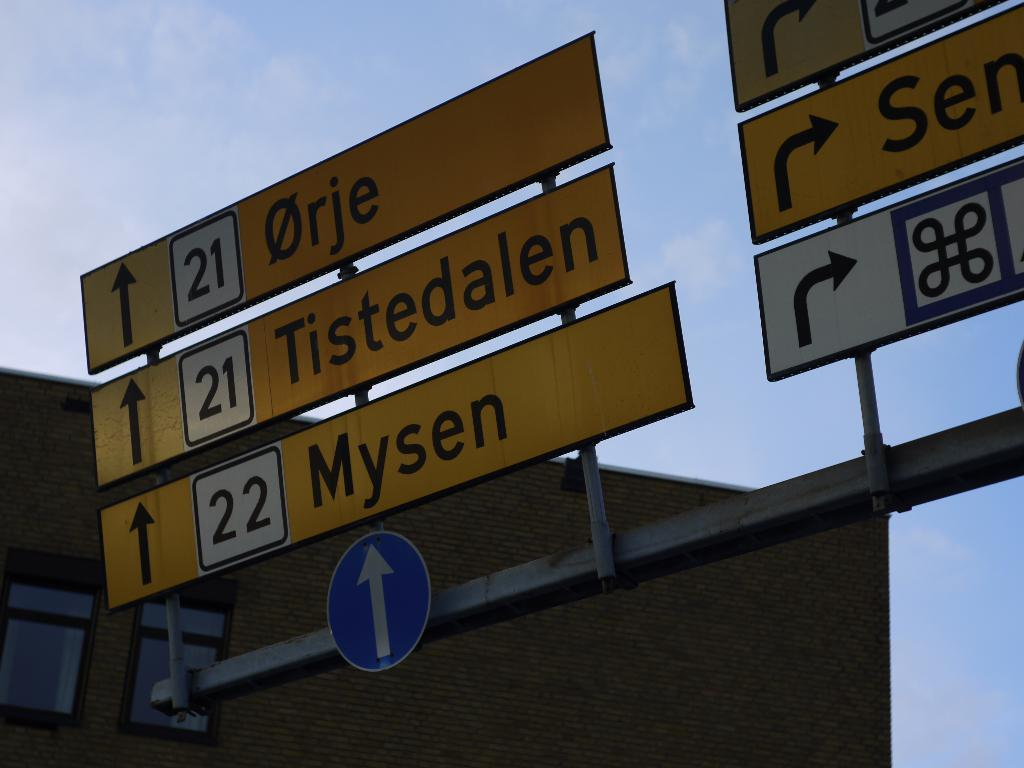What is located in the center of the image? There are sign boards in the center of the image. What can be seen on the sign boards? There is writing on the sign boards. What is visible in the background of the image? Sky, clouds, and a building are visible in the background of the image. What type of toy can be seen in the hands of the crook in the image? There is no crook or toy present in the image. 